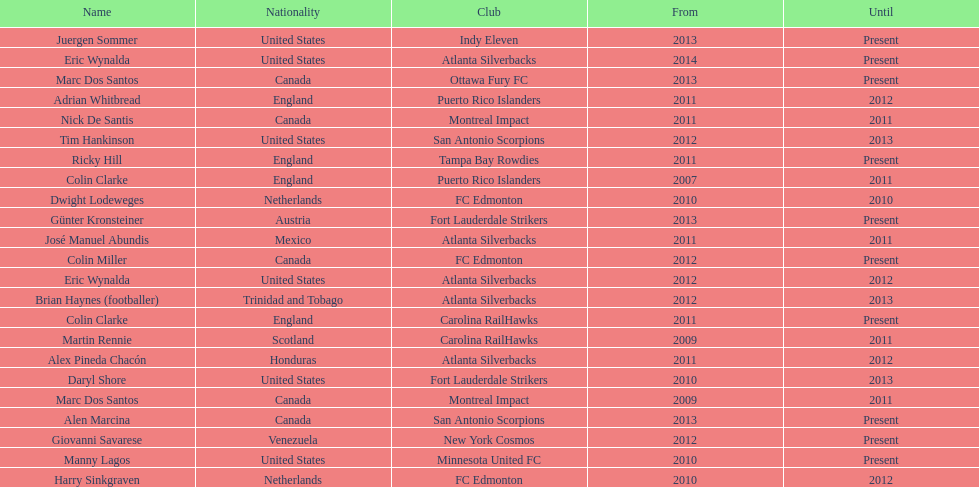Who coached the silverbacks longer, abundis or chacon? Chacon. 